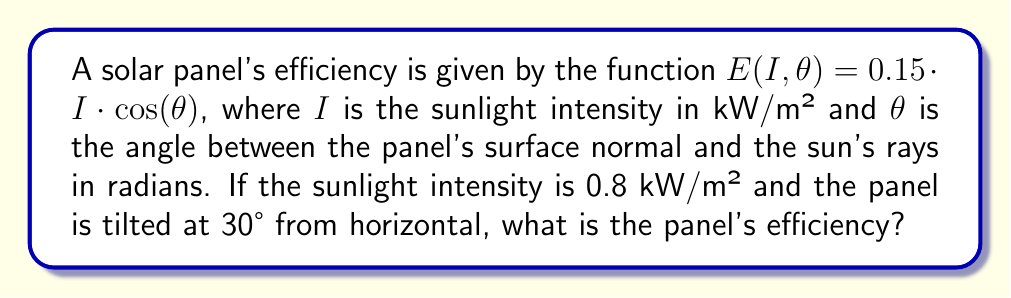Teach me how to tackle this problem. To solve this problem, we'll follow these steps:

1. Identify the given values:
   - Sunlight intensity, $I = 0.8$ kW/m²
   - Panel tilt angle = 30° from horizontal

2. Determine the angle $\theta$ between the panel's surface normal and the sun's rays:
   - When the panel is horizontal (0°), $\theta = 90°$
   - Since the panel is tilted 30° from horizontal, $\theta = 90° - 30° = 60°$

3. Convert $\theta$ from degrees to radians:
   $\theta_{rad} = 60° \cdot \frac{\pi}{180°} = \frac{\pi}{3}$ radians

4. Apply the efficiency function:
   $$E(I, \theta) = 0.15 \cdot I \cdot \cos(\theta)$$
   $$E(0.8, \frac{\pi}{3}) = 0.15 \cdot 0.8 \cdot \cos(\frac{\pi}{3})$$

5. Calculate the cosine of $\frac{\pi}{3}$:
   $$\cos(\frac{\pi}{3}) = 0.5$$

6. Compute the final result:
   $$E(0.8, \frac{\pi}{3}) = 0.15 \cdot 0.8 \cdot 0.5 = 0.06$$

Therefore, the panel's efficiency is 0.06 or 6%.
Answer: 0.06 (or 6%) 